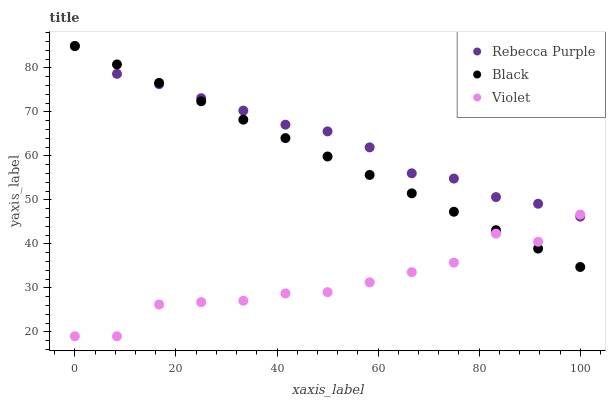Does Violet have the minimum area under the curve?
Answer yes or no. Yes. Does Rebecca Purple have the maximum area under the curve?
Answer yes or no. Yes. Does Rebecca Purple have the minimum area under the curve?
Answer yes or no. No. Does Violet have the maximum area under the curve?
Answer yes or no. No. Is Black the smoothest?
Answer yes or no. Yes. Is Violet the roughest?
Answer yes or no. Yes. Is Rebecca Purple the smoothest?
Answer yes or no. No. Is Rebecca Purple the roughest?
Answer yes or no. No. Does Violet have the lowest value?
Answer yes or no. Yes. Does Rebecca Purple have the lowest value?
Answer yes or no. No. Does Rebecca Purple have the highest value?
Answer yes or no. Yes. Does Violet have the highest value?
Answer yes or no. No. Does Black intersect Rebecca Purple?
Answer yes or no. Yes. Is Black less than Rebecca Purple?
Answer yes or no. No. Is Black greater than Rebecca Purple?
Answer yes or no. No. 